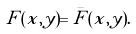Convert formula to latex. <formula><loc_0><loc_0><loc_500><loc_500>F ( x , y ) = \bar { F } ( x , y ) .</formula> 